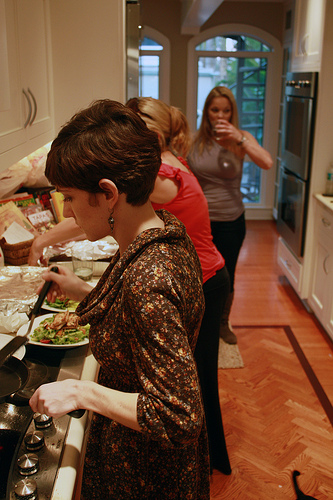How many people are in the kitchen? There are three people in the kitchen, busy with different activities. Describe the actions of the people in the kitchen. The woman in the foreground is cooking at the stove, possibly stirring something in a pan. The woman in the red shirt is also engaged in food preparation, facing the counter. The third woman standing at the back of the kitchen is drinking from a cup. What can you infer about the atmosphere in the kitchen? The kitchen seems to have a warm and busy atmosphere, with multiple people engaged in cooking and preparing meals. The presence of three individuals, each involved in specific tasks, suggests that it is a collaborative and dynamic environment, possibly in preparation for a gathering or meal. Create a story based on the image in the kitchen, be very creative! In the cozy kitchen of the enchanted cottage, three friends prepared for their mystical midnight feast. Penelope, the master potion brewer, stirred her magical stew that bubbled with flavors unknown to the mortal world. Lily, the guardian of endless recipes, meticulously chopped enchanted vegetables that shimmered with ethereal light. At the back, Serena, the spell-scriber, took a sip of her elixir reflecting moonbeams in her cup, crafting spells for the night's celebration. The aroma of their creations floated through the air, promising an evening of enchantment and delight. 